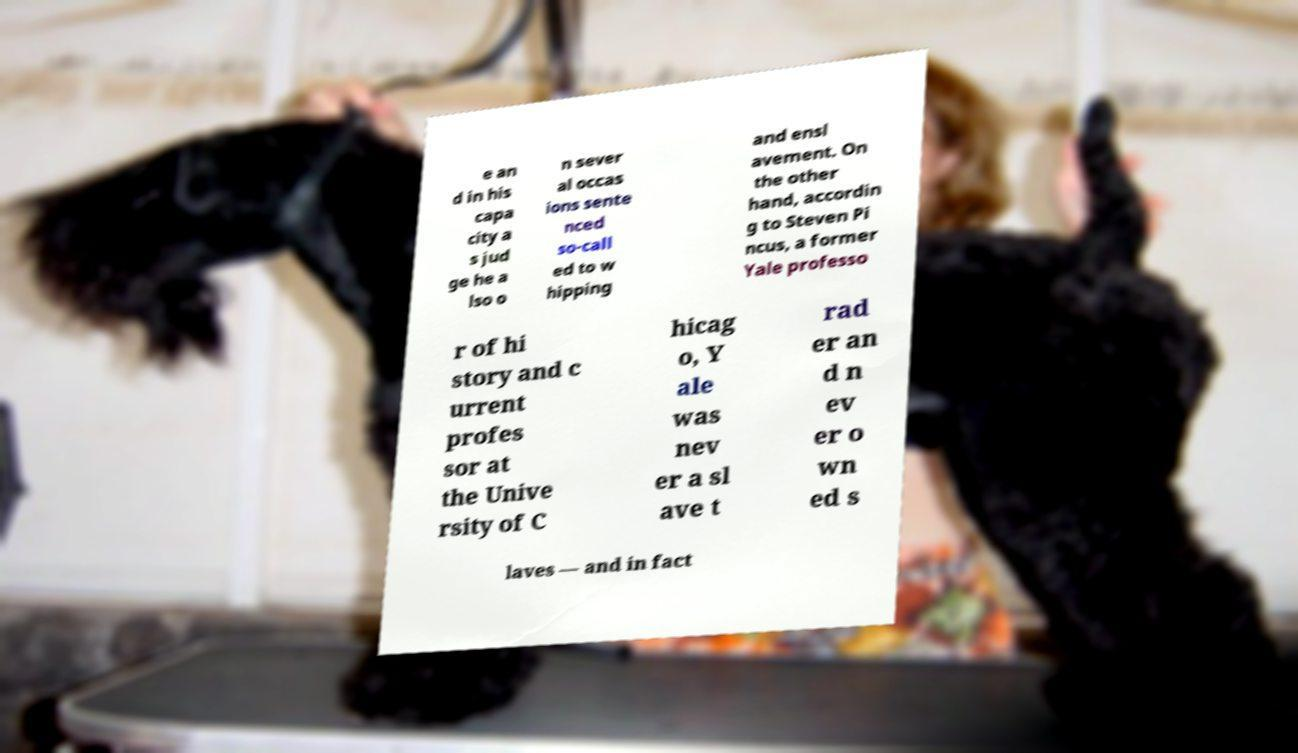Could you assist in decoding the text presented in this image and type it out clearly? e an d in his capa city a s jud ge he a lso o n sever al occas ions sente nced so-call ed to w hipping and ensl avement. On the other hand, accordin g to Steven Pi ncus, a former Yale professo r of hi story and c urrent profes sor at the Unive rsity of C hicag o, Y ale was nev er a sl ave t rad er an d n ev er o wn ed s laves — and in fact 